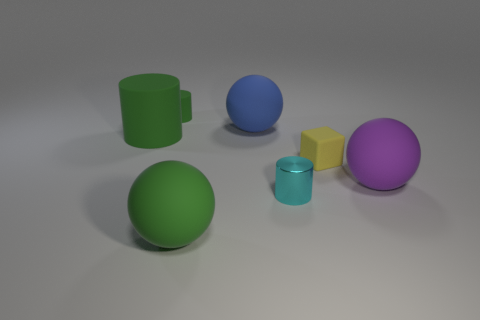What number of objects are either yellow matte blocks or things left of the cyan shiny cylinder?
Your answer should be very brief. 5. Is the number of big things behind the small yellow rubber cube greater than the number of big blue matte balls right of the small cyan cylinder?
Provide a short and direct response. Yes. There is a green rubber thing on the left side of the tiny object left of the big ball left of the large blue ball; what is its shape?
Your response must be concise. Cylinder. What shape is the big thing behind the big green thing behind the large purple thing?
Your answer should be very brief. Sphere. Are there any red cylinders that have the same material as the yellow thing?
Your answer should be very brief. No. There is another cylinder that is the same color as the large rubber cylinder; what is its size?
Keep it short and to the point. Small. How many green things are small matte objects or large rubber spheres?
Provide a short and direct response. 2. Are there any rubber balls that have the same color as the large rubber cylinder?
Offer a terse response. Yes. The green sphere that is the same material as the large green cylinder is what size?
Give a very brief answer. Large. What number of spheres are large blue objects or metal objects?
Your answer should be very brief. 1. 